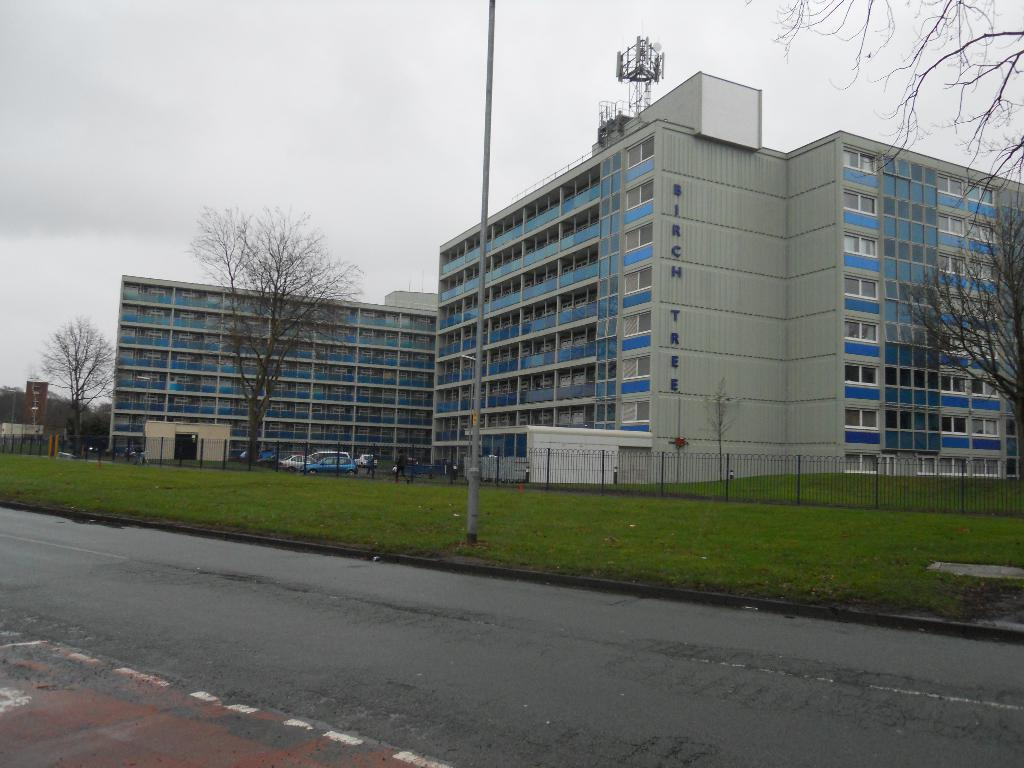What is located in the center of the image? There are buildings, cars, and trees in the center of the image. What can be seen at the bottom of the image? There is grass, a road, and fencing at the bottom of the image. What is visible in the background of the image? The sky is visible in the background of the image, with clouds present. Can you see a chicken kicking a ball in the image? There is no chicken or ball present in the image. Is there a boy playing with a toy car in the image? There is no boy or toy car present in the image. 